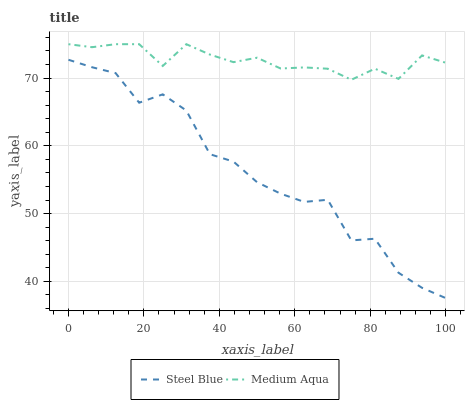Does Steel Blue have the minimum area under the curve?
Answer yes or no. Yes. Does Medium Aqua have the maximum area under the curve?
Answer yes or no. Yes. Does Steel Blue have the maximum area under the curve?
Answer yes or no. No. Is Medium Aqua the smoothest?
Answer yes or no. Yes. Is Steel Blue the roughest?
Answer yes or no. Yes. Is Steel Blue the smoothest?
Answer yes or no. No. Does Medium Aqua have the highest value?
Answer yes or no. Yes. Does Steel Blue have the highest value?
Answer yes or no. No. Is Steel Blue less than Medium Aqua?
Answer yes or no. Yes. Is Medium Aqua greater than Steel Blue?
Answer yes or no. Yes. Does Steel Blue intersect Medium Aqua?
Answer yes or no. No. 